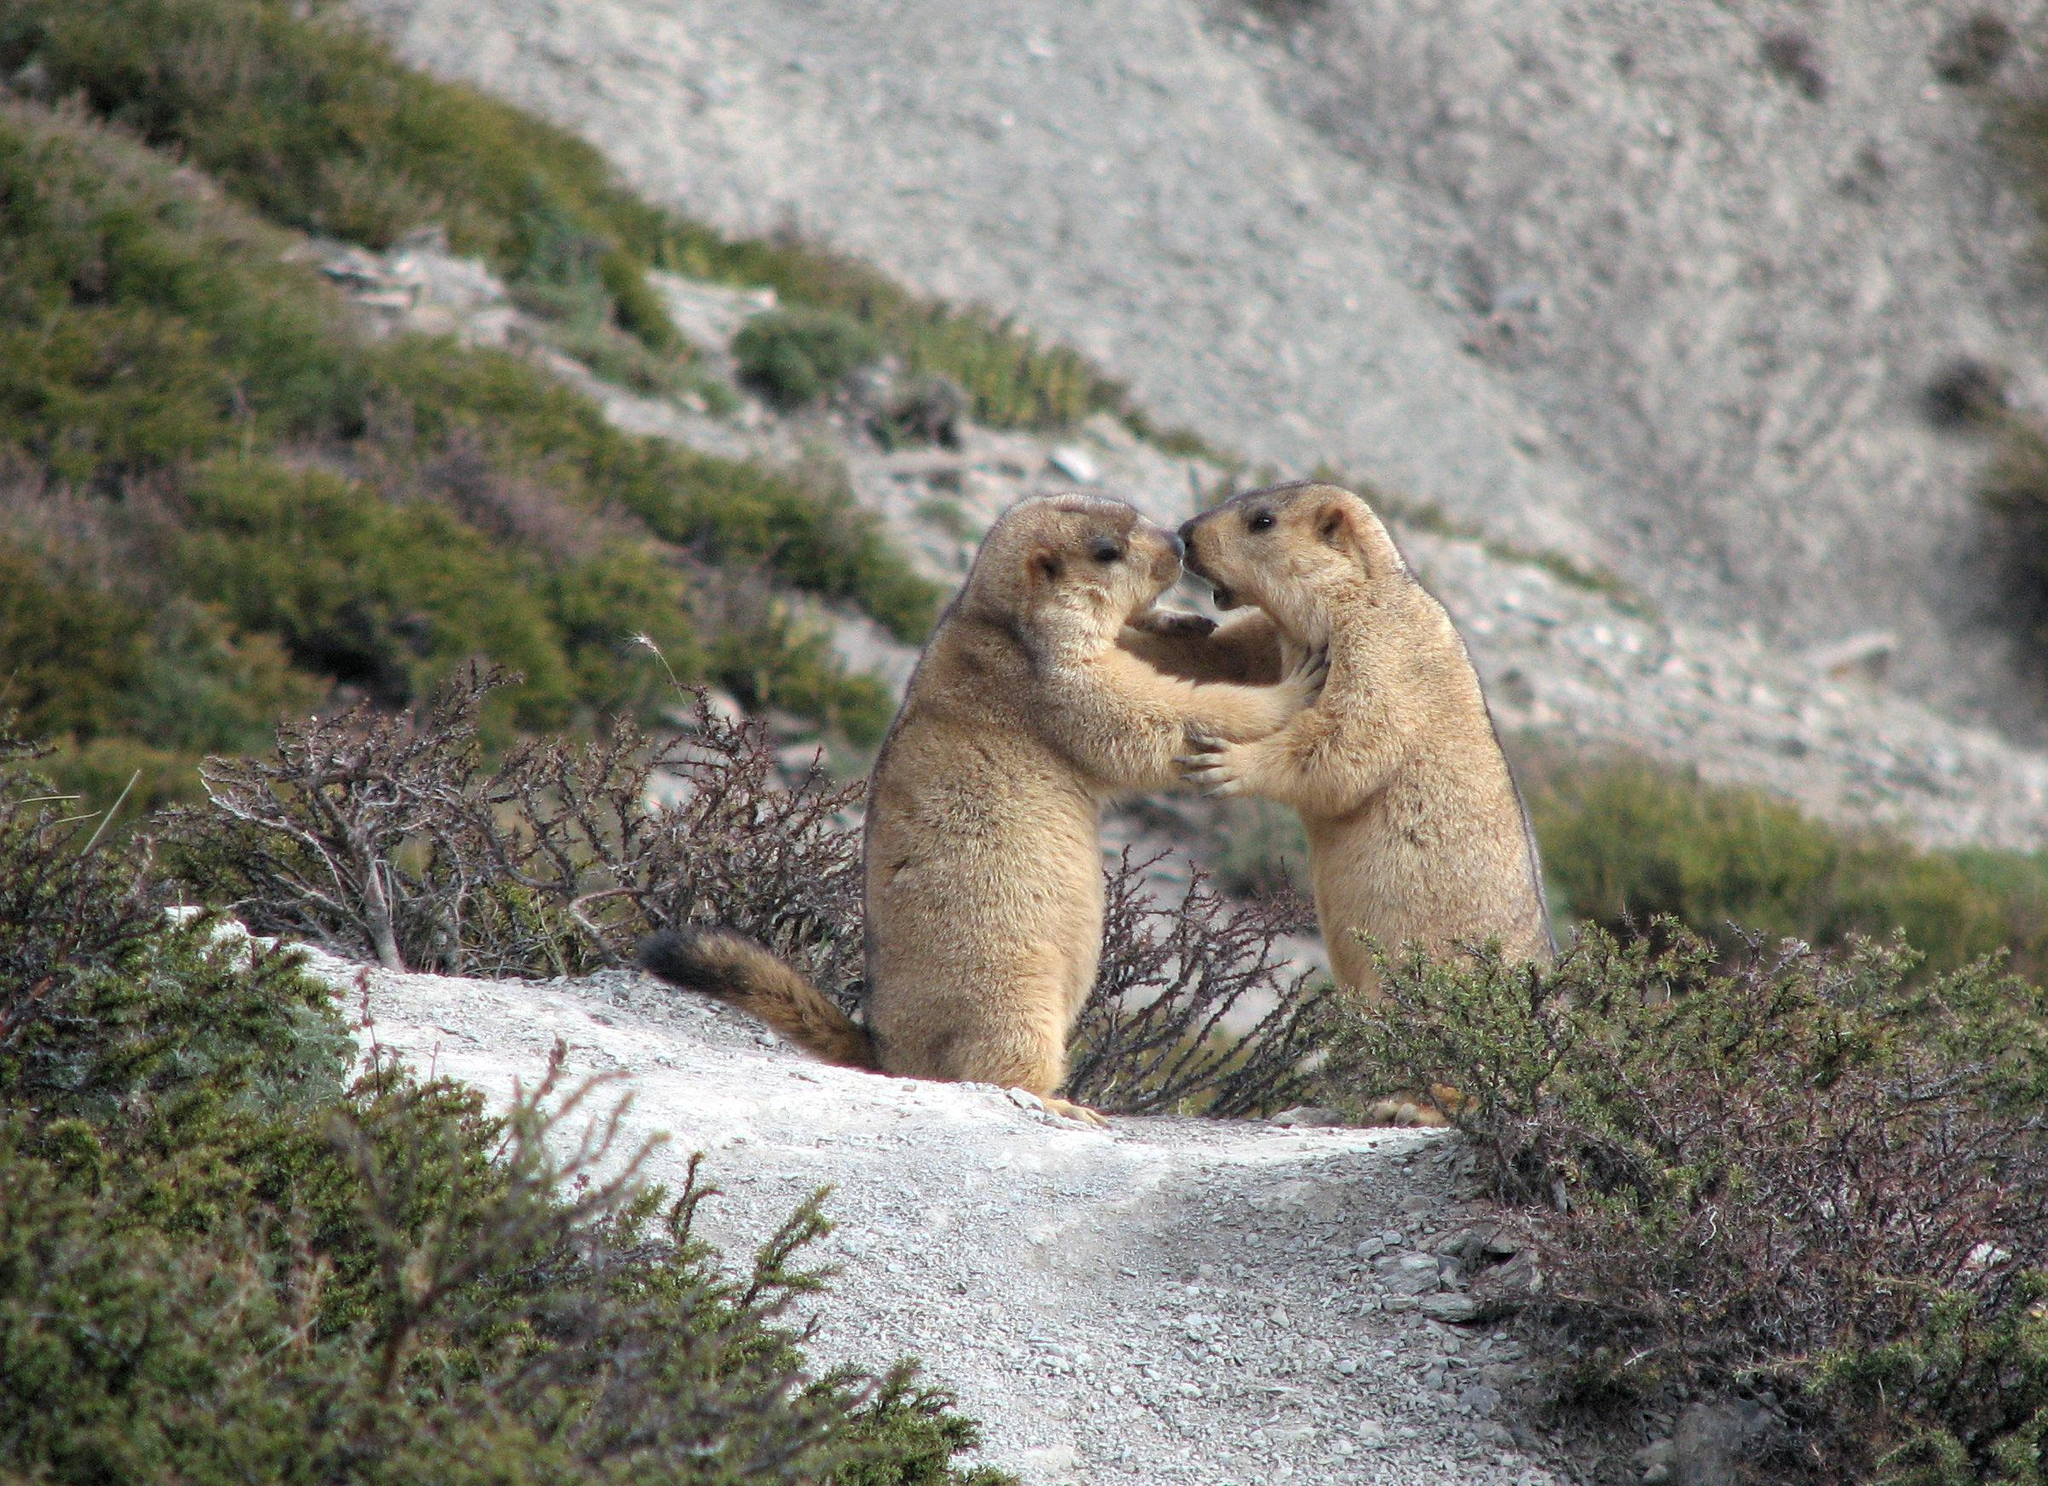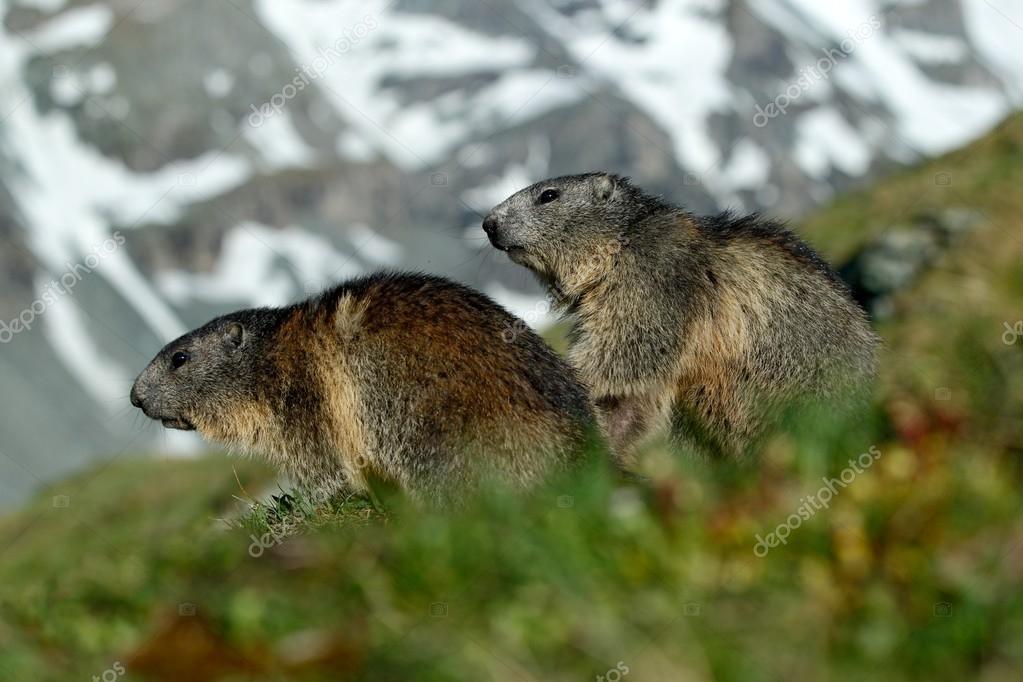The first image is the image on the left, the second image is the image on the right. For the images shown, is this caption "There are two rodents in the right image that are facing towards the right." true? Answer yes or no. No. 